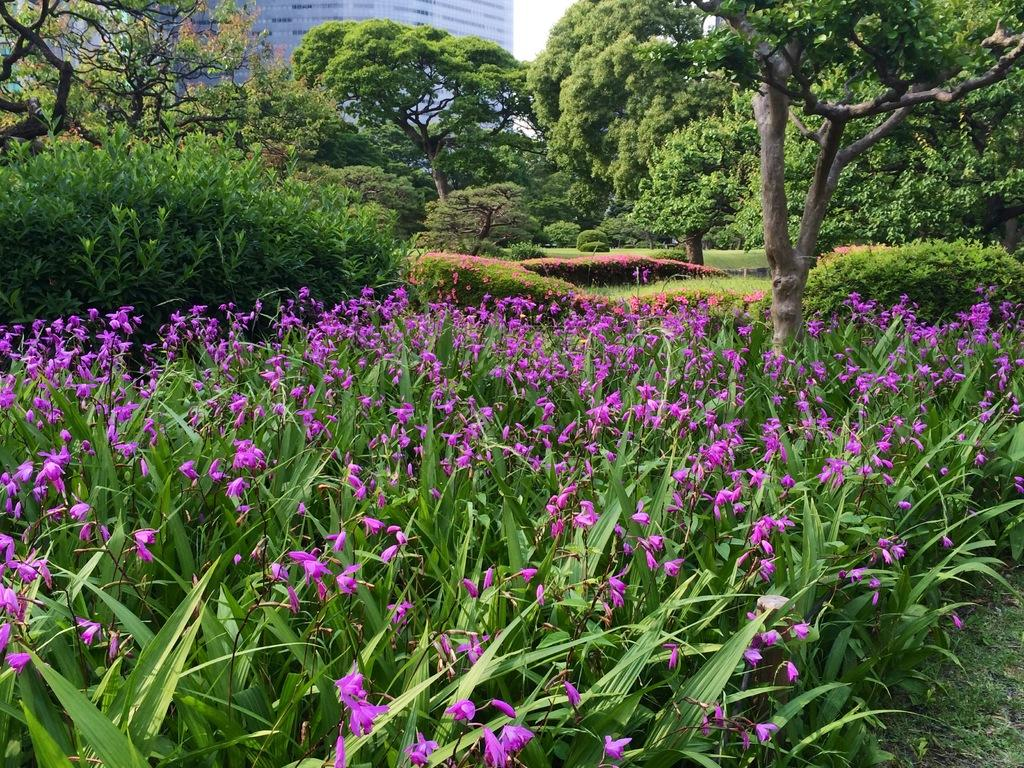What color are the flowers in the image? The flowers in the image are purple colored. Where are the flowers located? The flowers are on plants. What can be seen in the background of the image? There are trees, a building, and the sky visible in the background of the image. What type of bubble can be seen floating near the flowers in the image? There is no bubble present in the image; it only features purple colored flowers on plants, trees, a building, and the sky in the background. 